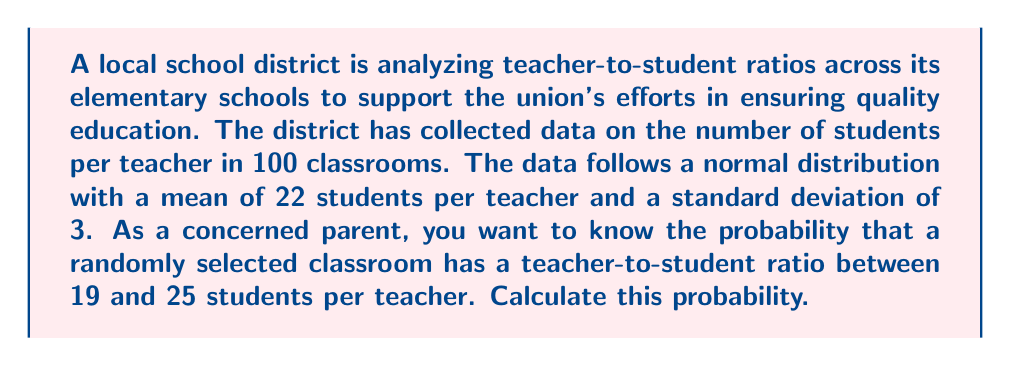Solve this math problem. To solve this problem, we'll use the properties of the normal distribution and the concept of z-scores.

1. We're given that the teacher-to-student ratio follows a normal distribution with:
   Mean (μ) = 22 students per teacher
   Standard deviation (σ) = 3 students

2. We need to find P(19 ≤ X ≤ 25), where X is the number of students per teacher.

3. To use the standard normal distribution, we need to convert these values to z-scores:

   For 19 students: $z_1 = \frac{19 - 22}{3} = -1$
   For 25 students: $z_2 = \frac{25 - 22}{3} = 1$

4. Now we need to find P(-1 ≤ Z ≤ 1), where Z is the standard normal variable.

5. Using a standard normal table or calculator:
   P(Z ≤ 1) = 0.8413
   P(Z ≤ -1) = 0.1587

6. The probability we're looking for is:
   P(-1 ≤ Z ≤ 1) = P(Z ≤ 1) - P(Z ≤ -1)
                 = 0.8413 - 0.1587
                 = 0.6826

7. Convert to a percentage: 0.6826 * 100 = 68.26%

Therefore, the probability that a randomly selected classroom has between 19 and 25 students per teacher is approximately 68.26%.
Answer: The probability is approximately 68.26%. 